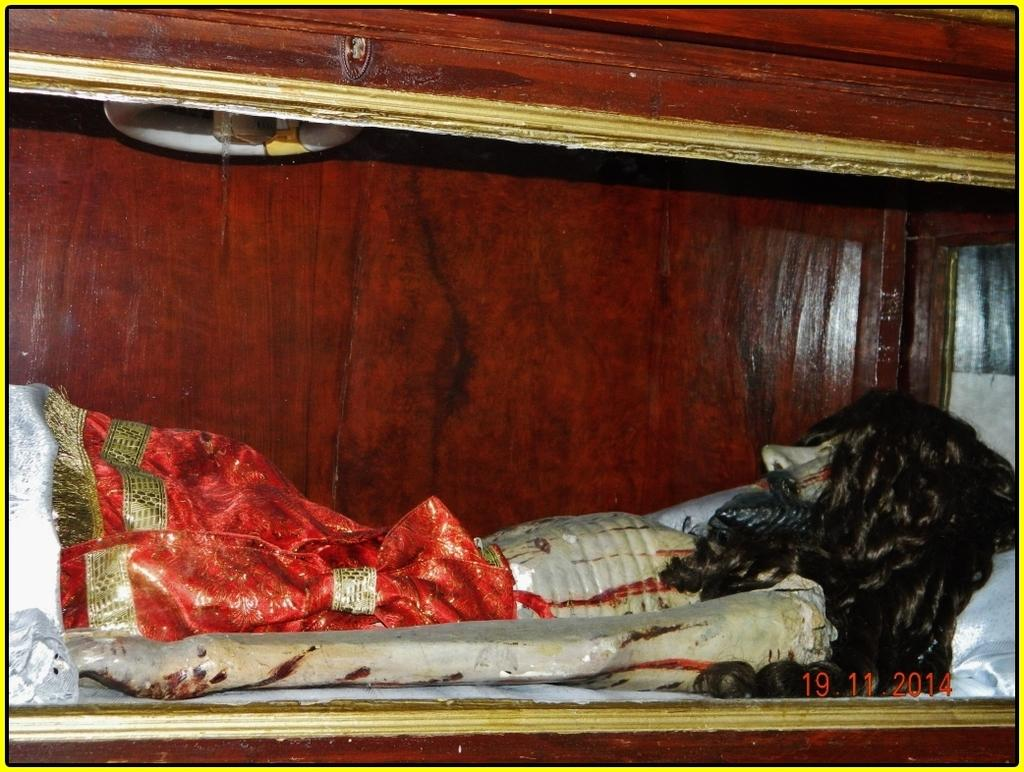What is the main subject of the image? There is a person statue in the image. What can be observed about the statue's appearance? The statue has hair and is wearing red-colored cloth. How is the statue being stored or displayed? The statue is kept in a wooden box. How many cows can be seen grazing near the statue in the image? There are no cows present in the image; it features a person statue kept in a wooden box. Are there any bikes visible in the image? There are no bikes visible in the image; it features a person statue kept in a wooden box. 